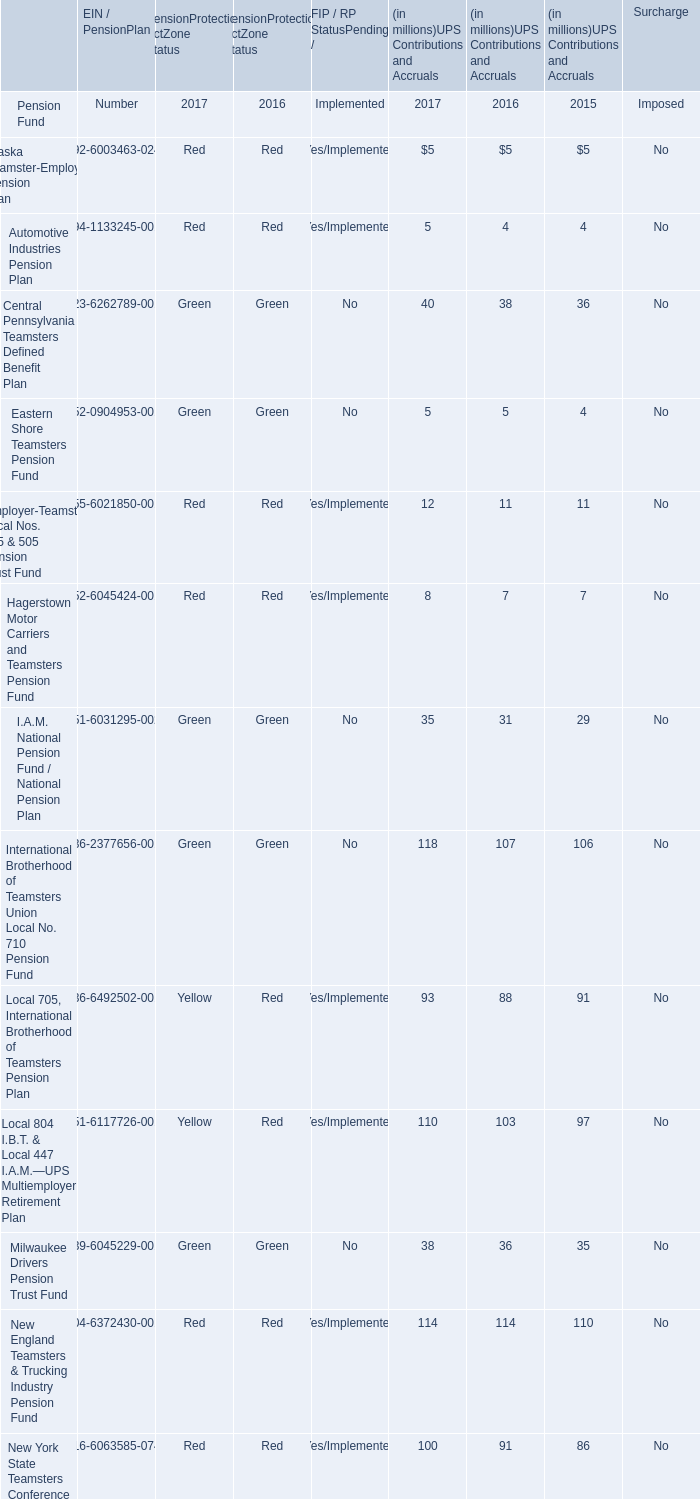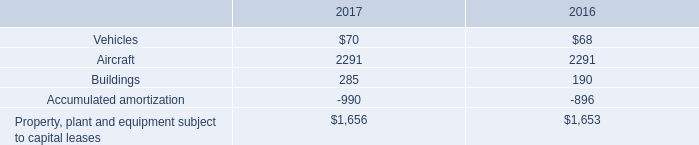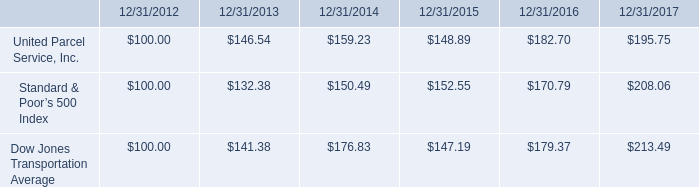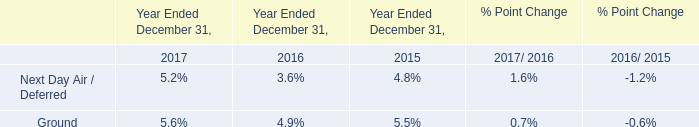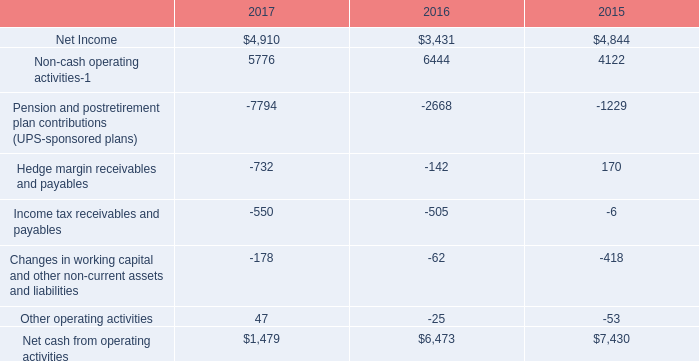what was the percentage change in vehicles under capital lease from 2016 to 2017? 
Computations: ((70 - 68) / 68)
Answer: 0.02941. 